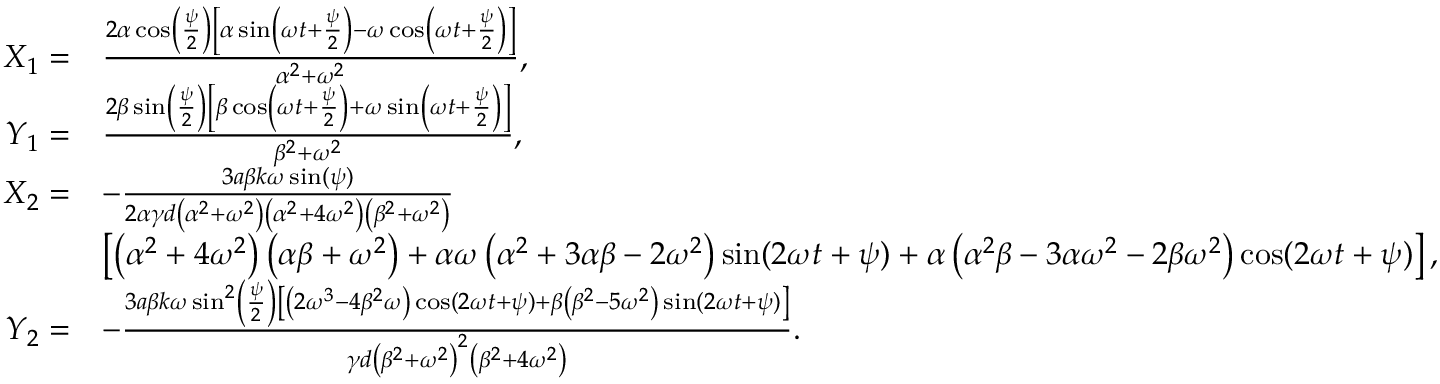<formula> <loc_0><loc_0><loc_500><loc_500>\begin{array} { r l } { { X } _ { 1 } = } & { \frac { 2 \alpha \cos \left ( \frac { \psi } { 2 } \right ) \left [ \alpha \sin \left ( \omega t + \frac { \psi } { 2 } \right ) - \omega \cos \left ( \omega t + \frac { \psi } { 2 } \right ) \right ] } { \alpha ^ { 2 } + \omega ^ { 2 } } , } \\ { { Y } _ { 1 } = } & { \frac { 2 \beta \sin \left ( \frac { \psi } { 2 } \right ) \left [ \beta \cos \left ( \omega t + \frac { \psi } { 2 } \right ) + \omega \sin \left ( \omega t + \frac { \psi } { 2 } \right ) \right ] } { \beta ^ { 2 } + \omega ^ { 2 } } , } \\ { { X } _ { 2 } = } & { - \frac { 3 a \beta k \omega \sin ( \psi ) } { 2 \alpha \gamma d \left ( \alpha ^ { 2 } + \omega ^ { 2 } \right ) \left ( \alpha ^ { 2 } + 4 \omega ^ { 2 } \right ) \left ( \beta ^ { 2 } + \omega ^ { 2 } \right ) } } \\ & { \left [ \left ( \alpha ^ { 2 } + 4 \omega ^ { 2 } \right ) \left ( \alpha \beta + \omega ^ { 2 } \right ) + \alpha \omega \left ( \alpha ^ { 2 } + 3 \alpha \beta - 2 \omega ^ { 2 } \right ) \sin ( 2 \omega t + \psi ) + \alpha \left ( \alpha ^ { 2 } \beta - 3 \alpha \omega ^ { 2 } - 2 \beta \omega ^ { 2 } \right ) \cos ( 2 \omega t + \psi ) \right ] , } \\ { { Y } _ { 2 } = } & { - \frac { 3 a \beta k \omega \sin ^ { 2 } \left ( \frac { \psi } { 2 } \right ) \left [ \left ( 2 \omega ^ { 3 } - 4 \beta ^ { 2 } \omega \right ) \cos ( 2 \omega t + \psi ) + \beta \left ( \beta ^ { 2 } - 5 \omega ^ { 2 } \right ) \sin ( 2 \omega t + \psi ) \right ] } { \gamma d \left ( \beta ^ { 2 } + \omega ^ { 2 } \right ) ^ { 2 } \left ( \beta ^ { 2 } + 4 \omega ^ { 2 } \right ) } . } \end{array}</formula> 